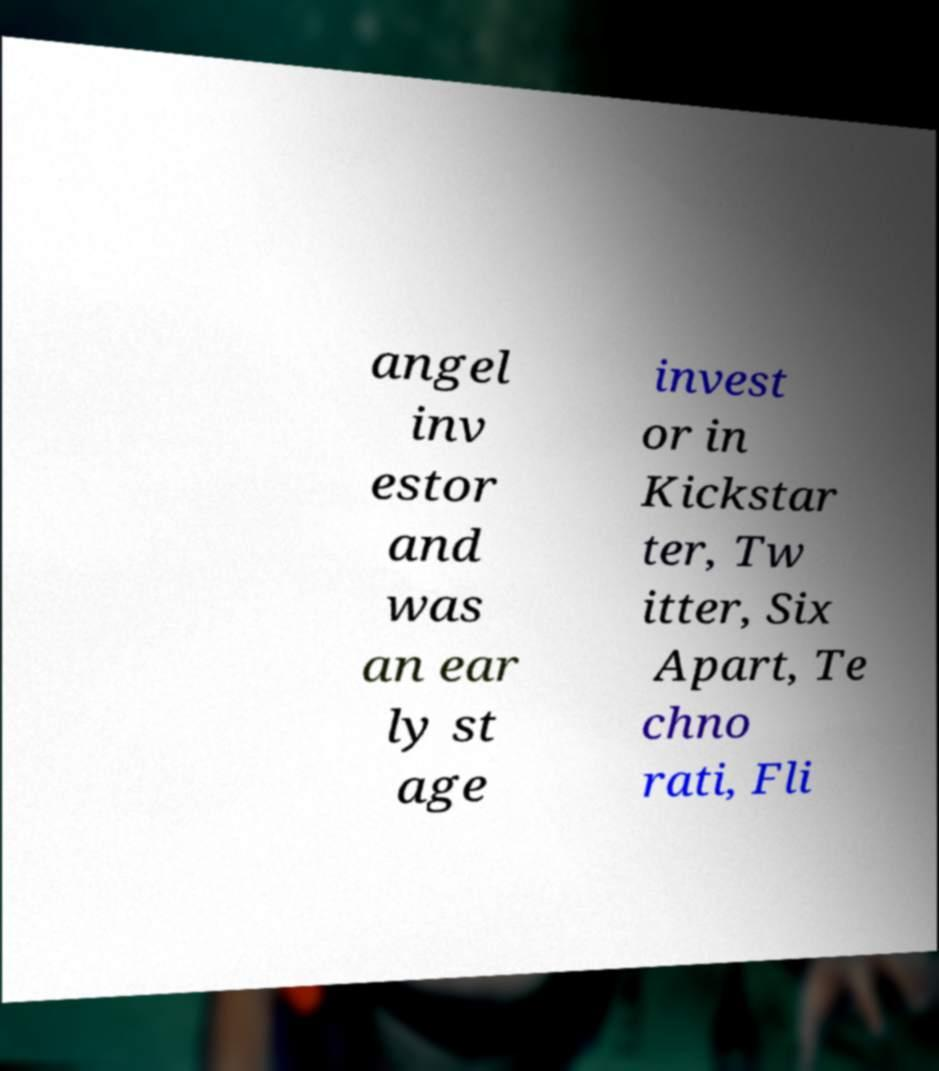For documentation purposes, I need the text within this image transcribed. Could you provide that? angel inv estor and was an ear ly st age invest or in Kickstar ter, Tw itter, Six Apart, Te chno rati, Fli 